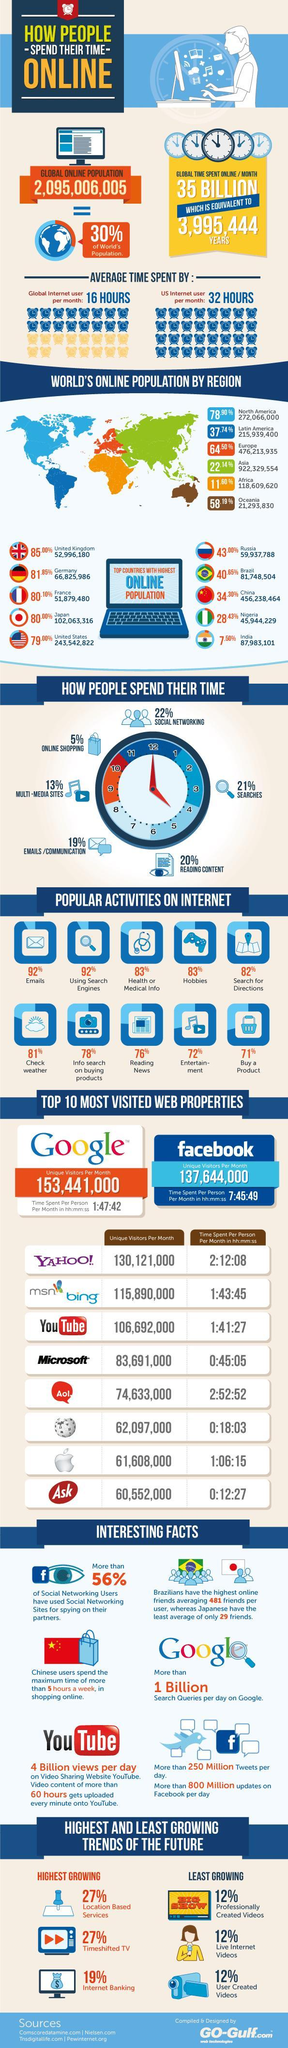Which country has the highest online population in the world among the top selected countries?
Answer the question with a short phrase. China How much time is spent per person per month (in hh:mm:ss) on iOS devices? 1:06:15 What is the online population of India? 87,983,101 Which continent in the world has the largest online population? Asia What is the number of unique visitors per month on youtube? 106,692,000 What percent of people worldwide spend time on internet for getting health information? 83% Which continent in the world has the least online population? Oceania What percent of people worldwide spend time on online shopping? 5% 